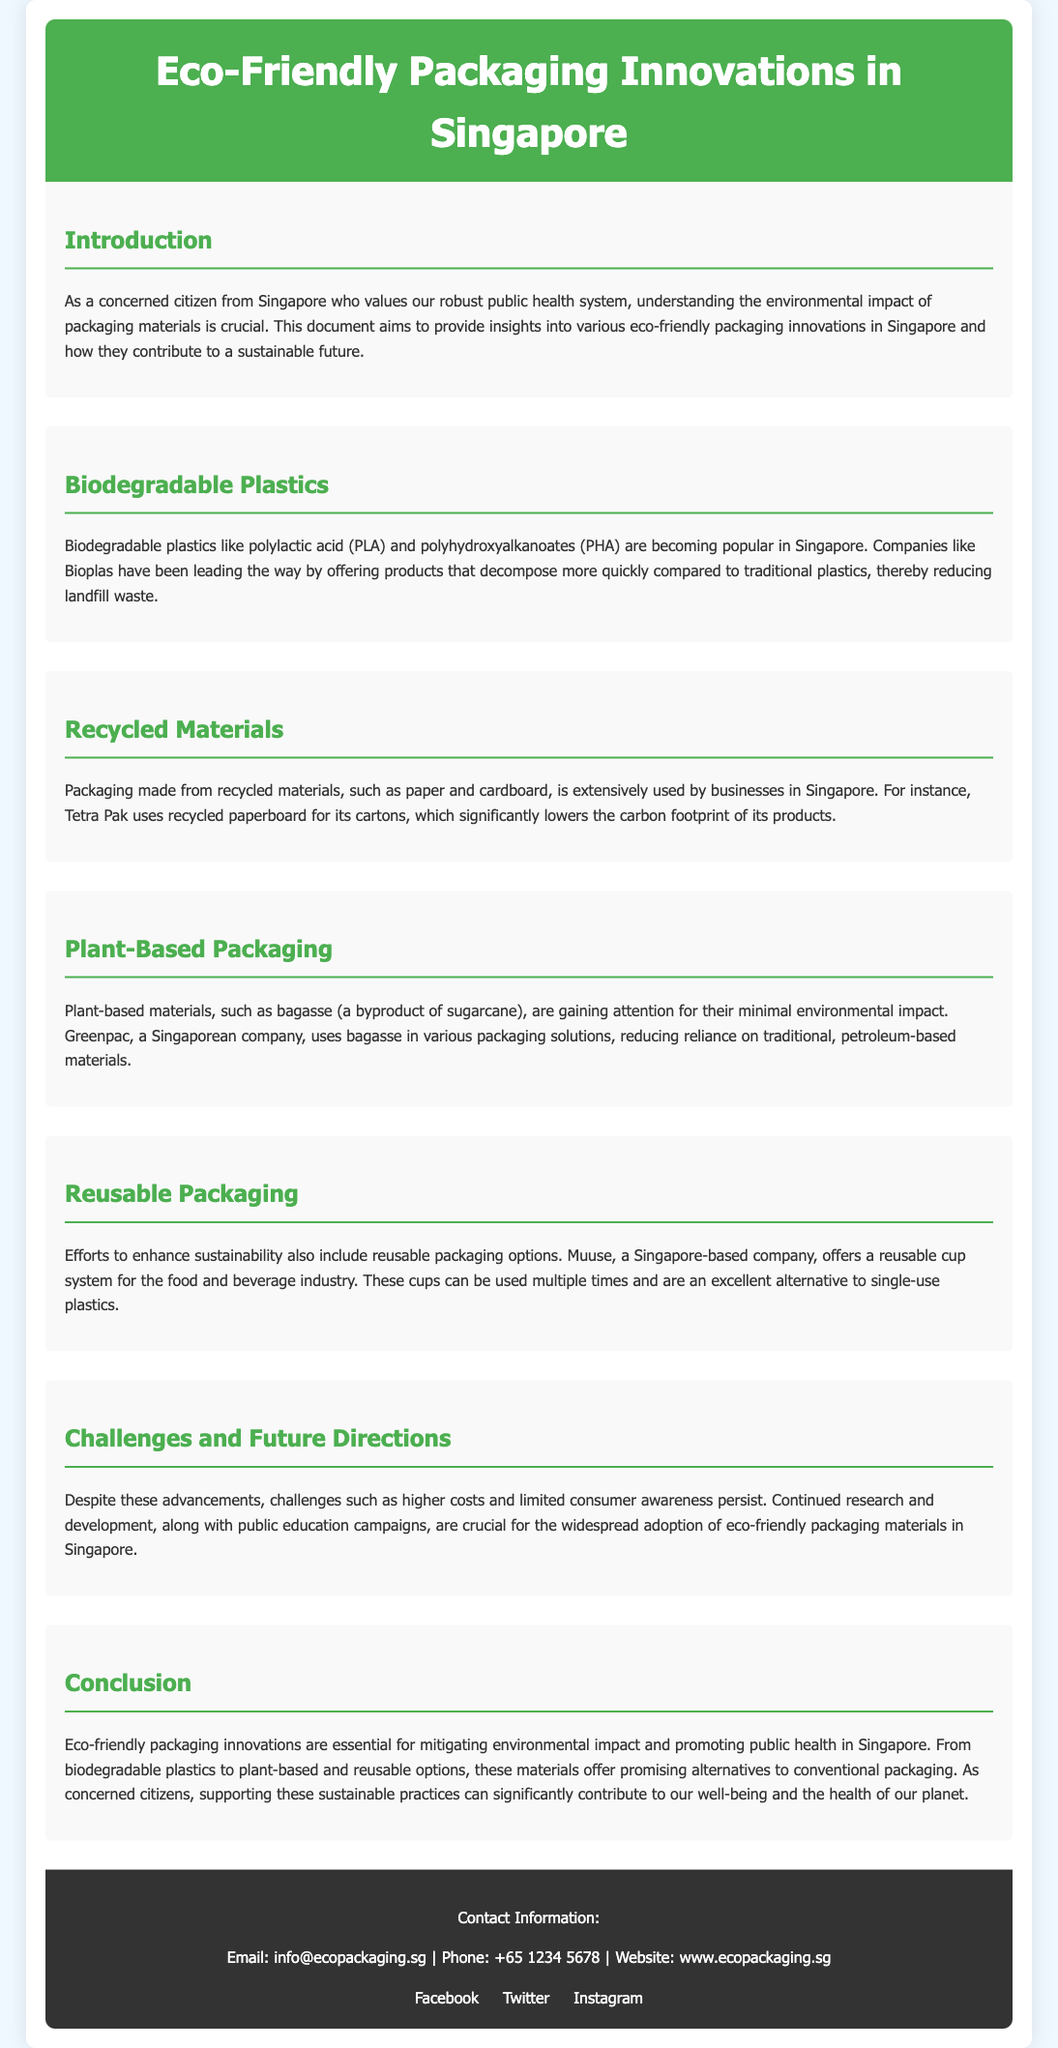What are biodegradable plastics made from? The document mentions polylactic acid (PLA) and polyhydroxyalkanoates (PHA) as examples of biodegradable plastics.
Answer: PLA and PHA Which company uses recycled paperboard for its cartons? The document states that Tetra Pak uses recycled paperboard for its cartons.
Answer: Tetra Pak What byproduct of sugarcane is used in plant-based packaging? The document refers to bagasse as the byproduct of sugarcane used in packaging.
Answer: Bagasse What kind of system does Muuse offer for the food and beverage industry? The document describes Muuse as offering a reusable cup system.
Answer: Reusable cup system What are two challenges mentioned in adopting eco-friendly packaging? The document highlights higher costs and limited consumer awareness as challenges.
Answer: Higher costs and limited consumer awareness What is the main focus of the document? The document aims to provide insights into eco-friendly packaging innovations and their environmental impact.
Answer: Eco-friendly packaging innovations How do biodegradable plastics help the environment compared to traditional plastics? The document explains that they decompose more quickly, thereby reducing landfill waste.
Answer: They decompose more quickly What is emphasized as crucial for widespread adoption of eco-friendly packaging? The document specifies continued research and public education campaigns as essential.
Answer: Research and public education campaigns 